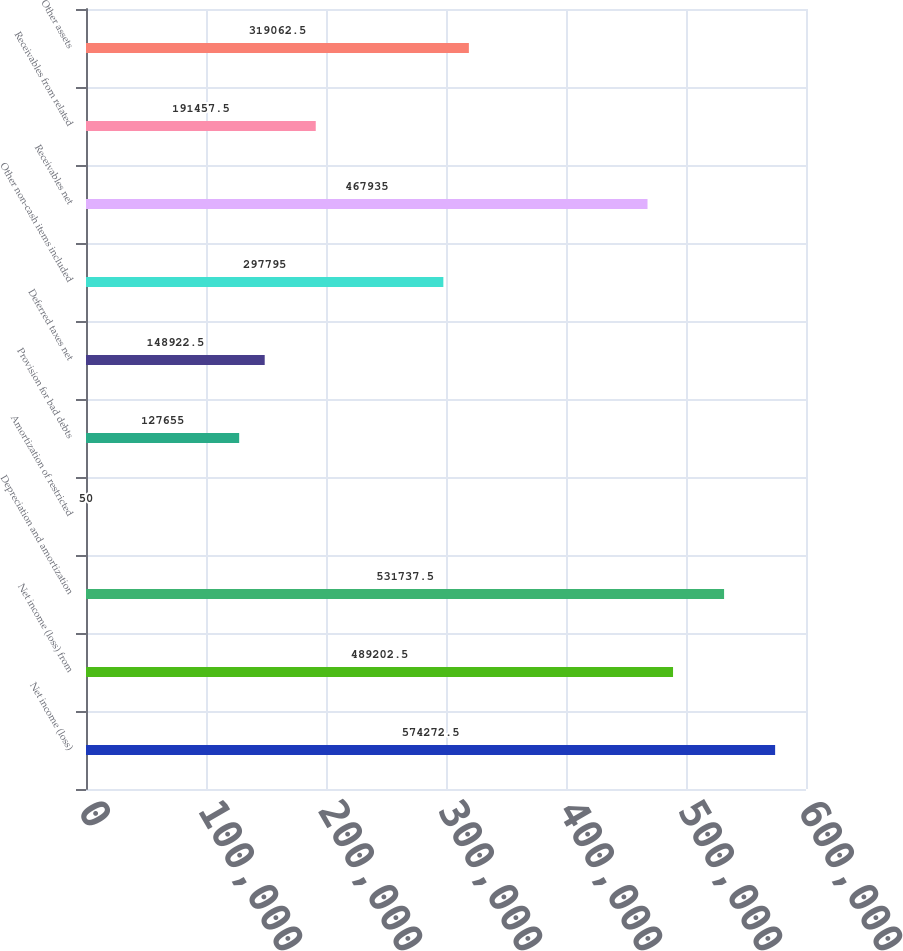Convert chart to OTSL. <chart><loc_0><loc_0><loc_500><loc_500><bar_chart><fcel>Net income (loss)<fcel>Net income (loss) from<fcel>Depreciation and amortization<fcel>Amortization of restricted<fcel>Provision for bad debts<fcel>Deferred taxes net<fcel>Other non-cash items included<fcel>Receivables net<fcel>Receivables from related<fcel>Other assets<nl><fcel>574272<fcel>489202<fcel>531738<fcel>50<fcel>127655<fcel>148922<fcel>297795<fcel>467935<fcel>191458<fcel>319062<nl></chart> 